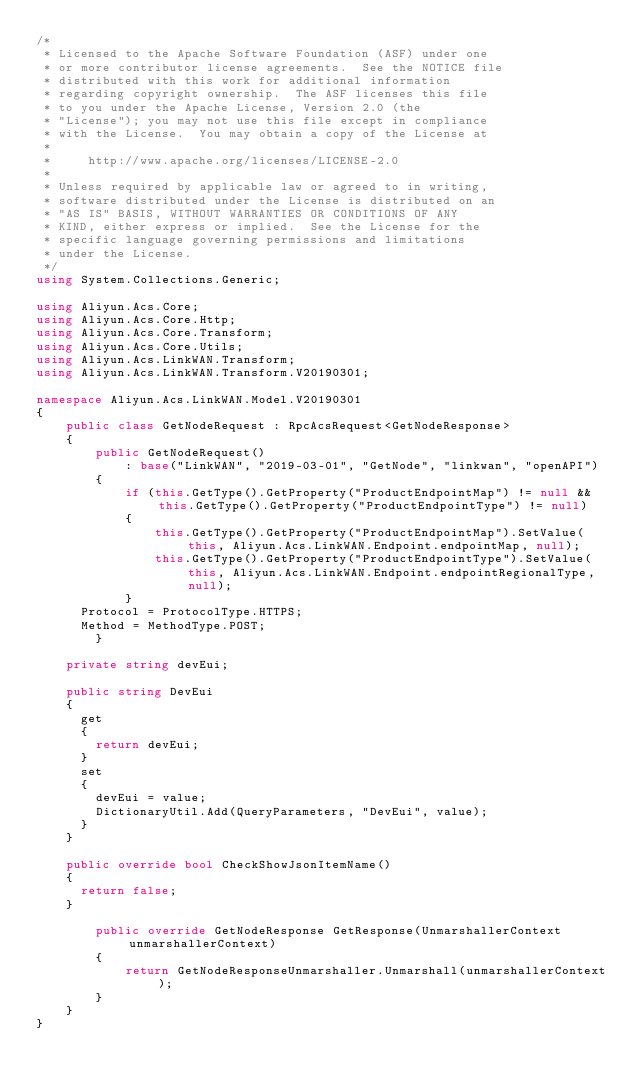Convert code to text. <code><loc_0><loc_0><loc_500><loc_500><_C#_>/*
 * Licensed to the Apache Software Foundation (ASF) under one
 * or more contributor license agreements.  See the NOTICE file
 * distributed with this work for additional information
 * regarding copyright ownership.  The ASF licenses this file
 * to you under the Apache License, Version 2.0 (the
 * "License"); you may not use this file except in compliance
 * with the License.  You may obtain a copy of the License at
 *
 *     http://www.apache.org/licenses/LICENSE-2.0
 *
 * Unless required by applicable law or agreed to in writing,
 * software distributed under the License is distributed on an
 * "AS IS" BASIS, WITHOUT WARRANTIES OR CONDITIONS OF ANY
 * KIND, either express or implied.  See the License for the
 * specific language governing permissions and limitations
 * under the License.
 */
using System.Collections.Generic;

using Aliyun.Acs.Core;
using Aliyun.Acs.Core.Http;
using Aliyun.Acs.Core.Transform;
using Aliyun.Acs.Core.Utils;
using Aliyun.Acs.LinkWAN.Transform;
using Aliyun.Acs.LinkWAN.Transform.V20190301;

namespace Aliyun.Acs.LinkWAN.Model.V20190301
{
    public class GetNodeRequest : RpcAcsRequest<GetNodeResponse>
    {
        public GetNodeRequest()
            : base("LinkWAN", "2019-03-01", "GetNode", "linkwan", "openAPI")
        {
            if (this.GetType().GetProperty("ProductEndpointMap") != null && this.GetType().GetProperty("ProductEndpointType") != null)
            {
                this.GetType().GetProperty("ProductEndpointMap").SetValue(this, Aliyun.Acs.LinkWAN.Endpoint.endpointMap, null);
                this.GetType().GetProperty("ProductEndpointType").SetValue(this, Aliyun.Acs.LinkWAN.Endpoint.endpointRegionalType, null);
            }
			Protocol = ProtocolType.HTTPS;
			Method = MethodType.POST;
        }

		private string devEui;

		public string DevEui
		{
			get
			{
				return devEui;
			}
			set	
			{
				devEui = value;
				DictionaryUtil.Add(QueryParameters, "DevEui", value);
			}
		}

		public override bool CheckShowJsonItemName()
		{
			return false;
		}

        public override GetNodeResponse GetResponse(UnmarshallerContext unmarshallerContext)
        {
            return GetNodeResponseUnmarshaller.Unmarshall(unmarshallerContext);
        }
    }
}
</code> 